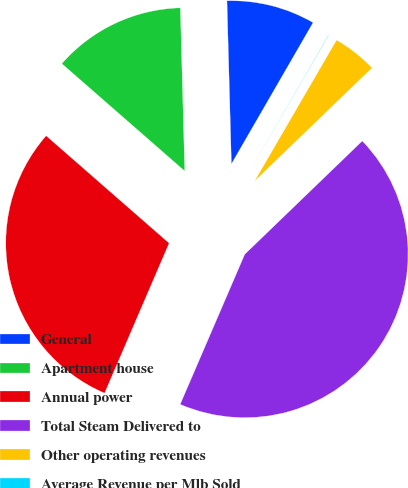Convert chart. <chart><loc_0><loc_0><loc_500><loc_500><pie_chart><fcel>General<fcel>Apartment house<fcel>Annual power<fcel>Total Steam Delivered to<fcel>Other operating revenues<fcel>Average Revenue per Mlb Sold<nl><fcel>8.77%<fcel>13.14%<fcel>29.96%<fcel>43.68%<fcel>4.41%<fcel>0.04%<nl></chart> 